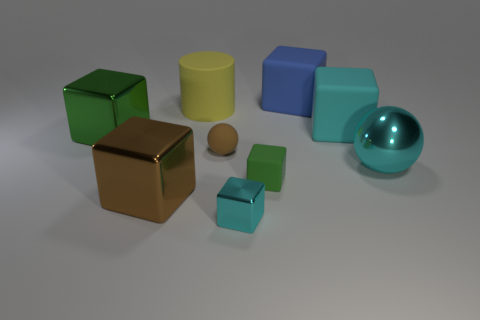Subtract all green balls. How many cyan cubes are left? 2 Subtract all big blocks. How many blocks are left? 2 Subtract 4 cubes. How many cubes are left? 2 Subtract all blue blocks. How many blocks are left? 5 Add 1 cyan cubes. How many objects exist? 10 Subtract all blue cubes. Subtract all brown cylinders. How many cubes are left? 5 Subtract all cylinders. How many objects are left? 8 Add 6 large cyan rubber cubes. How many large cyan rubber cubes are left? 7 Add 2 brown balls. How many brown balls exist? 3 Subtract 0 purple cylinders. How many objects are left? 9 